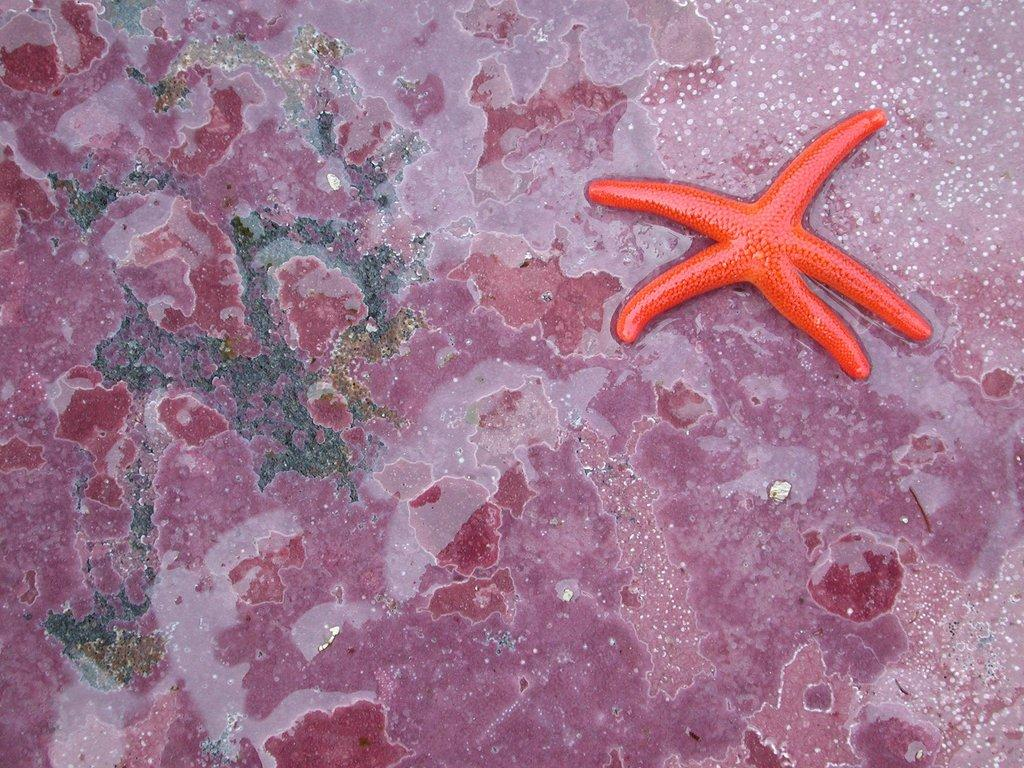What is the main subject of the image? The main subject of the image is a starfish. Where is the starfish located in the image? The starfish is located in the center of the image. What type of lettuce is being used to show off the starfish in the image? There is no lettuce present in the image, and the starfish is not being used for any show-off purposes. 